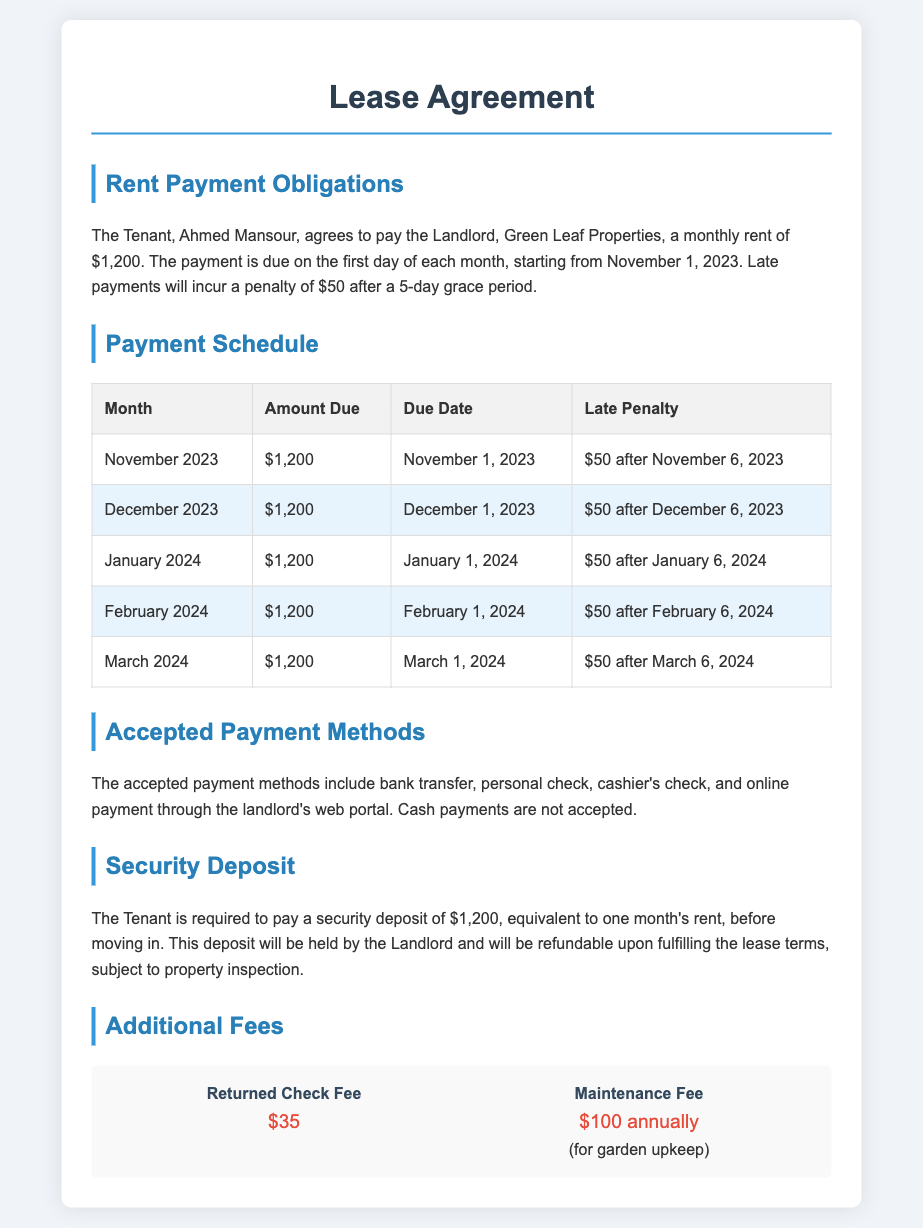What is the monthly rent? The monthly rent is explicitly stated in the document as $1,200.
Answer: $1,200 When is the rent due each month? The document specifies that rent is due on the first day of each month.
Answer: First day of each month What is the late penalty amount? The late penalty for delayed payment is mentioned as $50 after a 5-day grace period.
Answer: $50 What is the security deposit amount? The security deposit required before moving in is equal to one month’s rent, which is $1,200.
Answer: $1,200 Which payment methods are accepted? The accepted payment methods are bank transfer, personal check, cashier's check, and online payment.
Answer: Bank transfer, personal check, cashier's check, online payment What additional fee is charged for a returned check? The document states the fee for a returned check as $35.
Answer: $35 How often is the maintenance fee charged? The maintenance fee is charged annually according to the lease agreement.
Answer: Annually What is the grace period for late rent payments? The grace period allowed before a late penalty is applied is 5 days.
Answer: 5 days Which month has the first rent payment due? The first rent payment is due in November 2023 as indicated in the schedule.
Answer: November 2023 